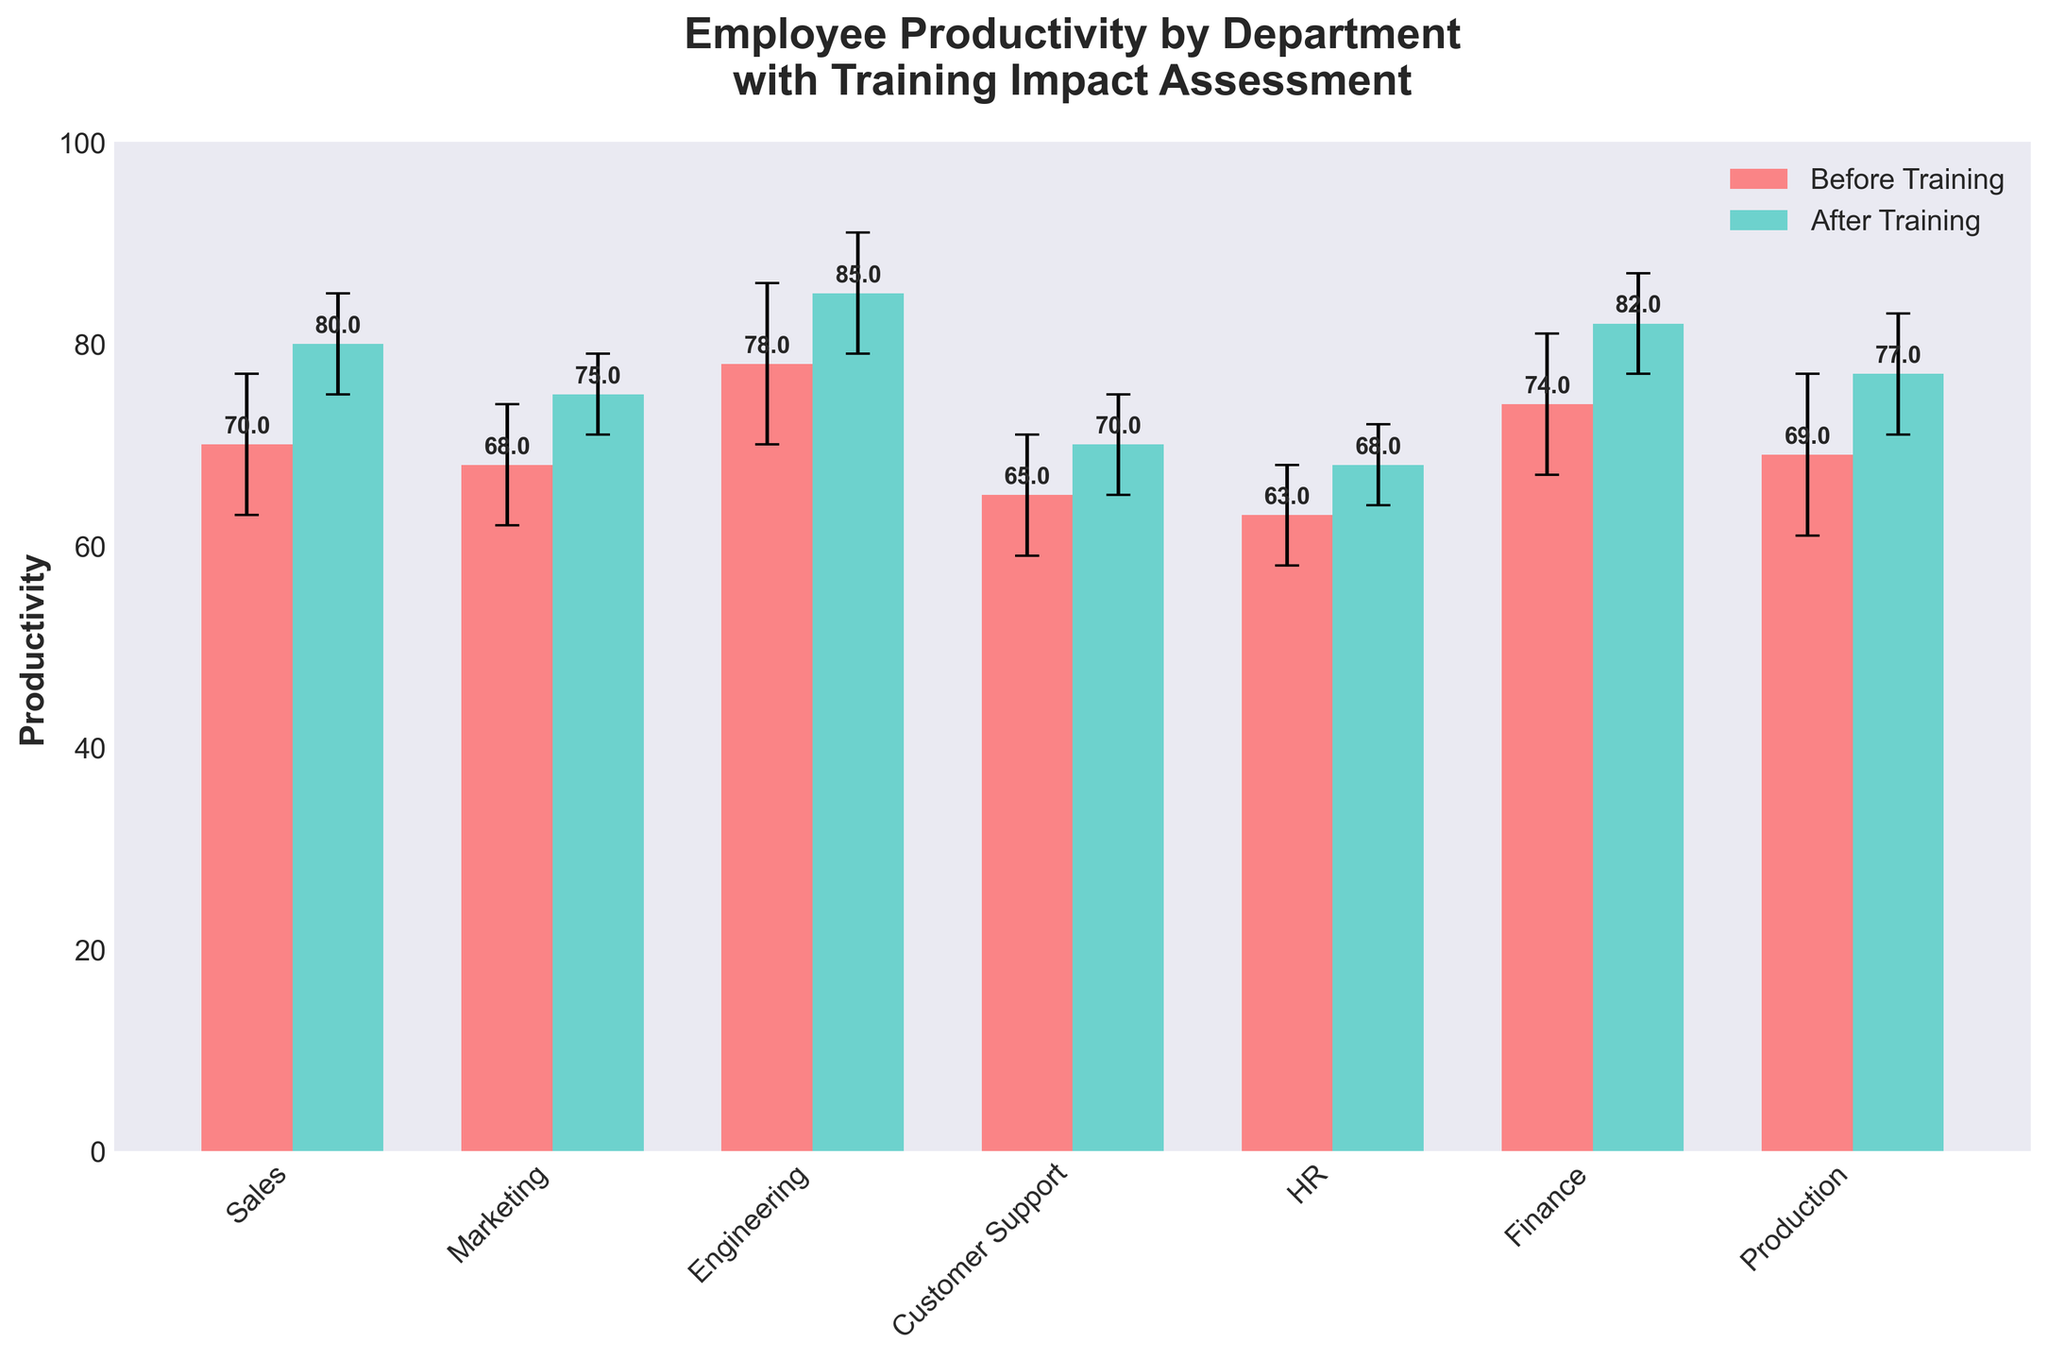What is the title of the figure? The title is usually located at the top of the figure, typically in bold and larger font size compared to the other text.
Answer: "Employee Productivity by Department with Training Impact Assessment" How many departments are included in the chart? Count the number of labels on the x-axis representing different departments.
Answer: 7 Which department shows the highest mean productivity after training? Compare the heights of the bars labeled "After Training" across all departments to find the tallest one.
Answer: Engineering What is the mean productivity before and after training for the Marketing department? Identify the heights of both "Before Training" and "After Training" bars for the Marketing department.
Answer: Before: 68, After: 75 Which department has the largest increase in mean productivity after training? Calculate the difference between the "After Training" and "Before Training" bars for each department, and identify the largest difference.
Answer: Sales (increase of 10) Are there any departments where the productivity decreased after training? Compare the heights of the "Before Training" and "After Training" bars for each department to check for any decreases.
Answer: No What is the range of standard deviations for productivity after training? Look at the error bars (caps) on the "After Training" bars to identify the smallest and largest standard deviations.
Answer: Range: 4 (HR), 6 (Engineering, Production) Which department shows the smallest standard deviation in productivity after training? Find the department with the shortest error bar (cap) on the "After Training" bar.
Answer: HR How does the mean productivity before training in the Sales department compare to the Customer Support department? Compare the heights of the "Before Training" bars for the Sales and Customer Support departments.
Answer: Sales: 70, Customer Support: 65 Is the overall trend of productivity positive after training across all departments? Determine if the heights of the "After Training" bars are generally higher than their corresponding "Before Training" bars.
Answer: Yes 